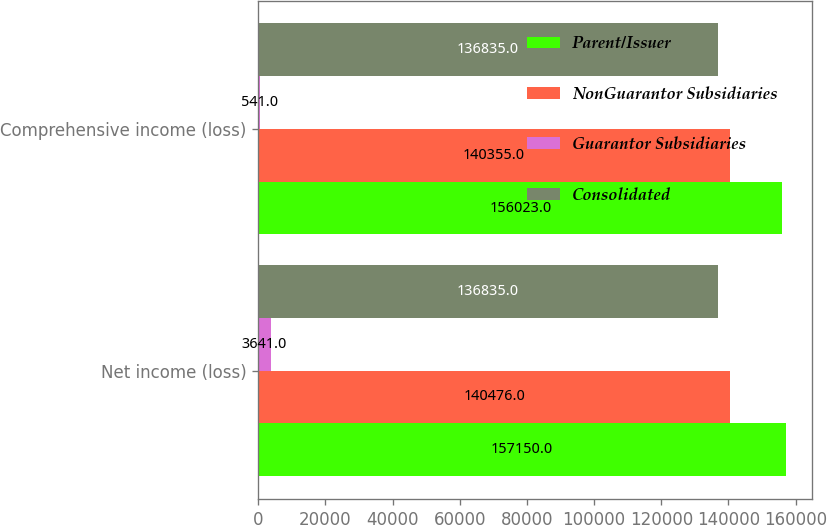Convert chart. <chart><loc_0><loc_0><loc_500><loc_500><stacked_bar_chart><ecel><fcel>Net income (loss)<fcel>Comprehensive income (loss)<nl><fcel>Parent/Issuer<fcel>157150<fcel>156023<nl><fcel>NonGuarantor Subsidiaries<fcel>140476<fcel>140355<nl><fcel>Guarantor Subsidiaries<fcel>3641<fcel>541<nl><fcel>Consolidated<fcel>136835<fcel>136835<nl></chart> 